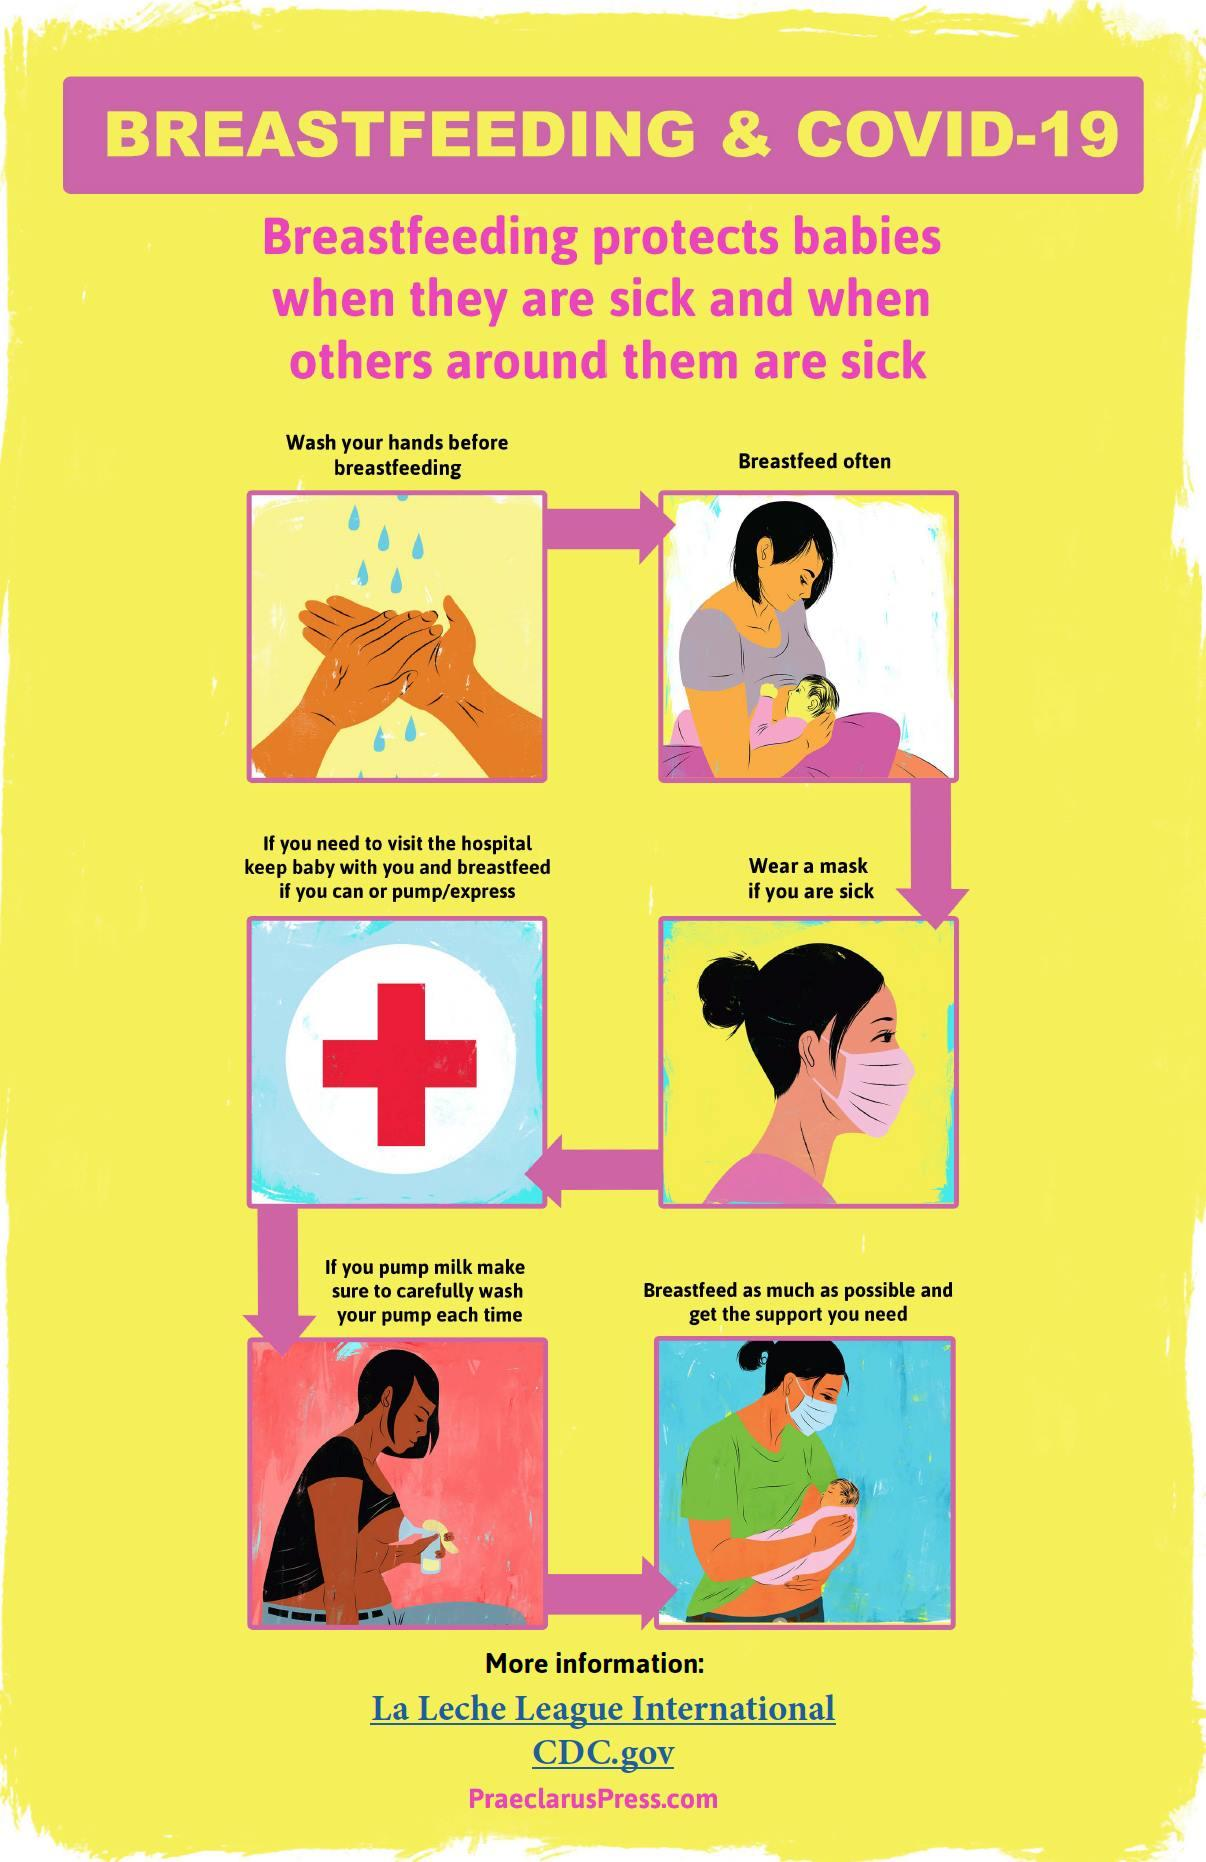List a handful of essential elements in this visual. The infographic image shows breastfeeding of babies two times. In the infographic image, two people were depicted wearing masks. 